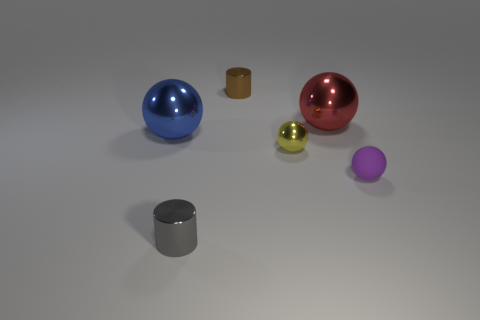Is there any other thing that is the same material as the purple sphere?
Your answer should be compact. No. Is the material of the small purple sphere the same as the cylinder that is in front of the small purple matte ball?
Your answer should be compact. No. Is the color of the matte object the same as the small shiny ball?
Offer a terse response. No. What material is the purple ball that is in front of the blue metal thing behind the tiny ball that is right of the big red shiny sphere?
Keep it short and to the point. Rubber. Are there any red shiny spheres in front of the small gray cylinder?
Provide a short and direct response. No. What is the shape of the yellow metal thing that is the same size as the gray metal object?
Give a very brief answer. Sphere. Is the material of the blue ball the same as the tiny purple thing?
Provide a succinct answer. No. How many matte objects are either brown objects or purple balls?
Give a very brief answer. 1. Does the shiny ball that is to the right of the small yellow metallic sphere have the same color as the matte thing?
Your answer should be very brief. No. The small shiny thing that is behind the big object that is to the left of the tiny yellow metallic thing is what shape?
Your answer should be compact. Cylinder. 